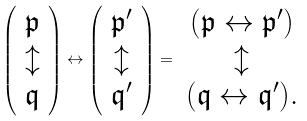Convert formula to latex. <formula><loc_0><loc_0><loc_500><loc_500>\left ( \begin{array} { c } \mathfrak p \\ \updownarrow \\ \mathfrak q \end{array} \right ) \leftrightarrow \left ( \begin{array} { c } \mathfrak p ^ { \prime } \\ \updownarrow \\ \mathfrak q ^ { \prime } \end{array} \right ) = \begin{array} { c } ( \mathfrak p \leftrightarrow \mathfrak p ^ { \prime } ) \\ \updownarrow \\ ( \mathfrak q \leftrightarrow \mathfrak q ^ { \prime } ) . \end{array}</formula> 